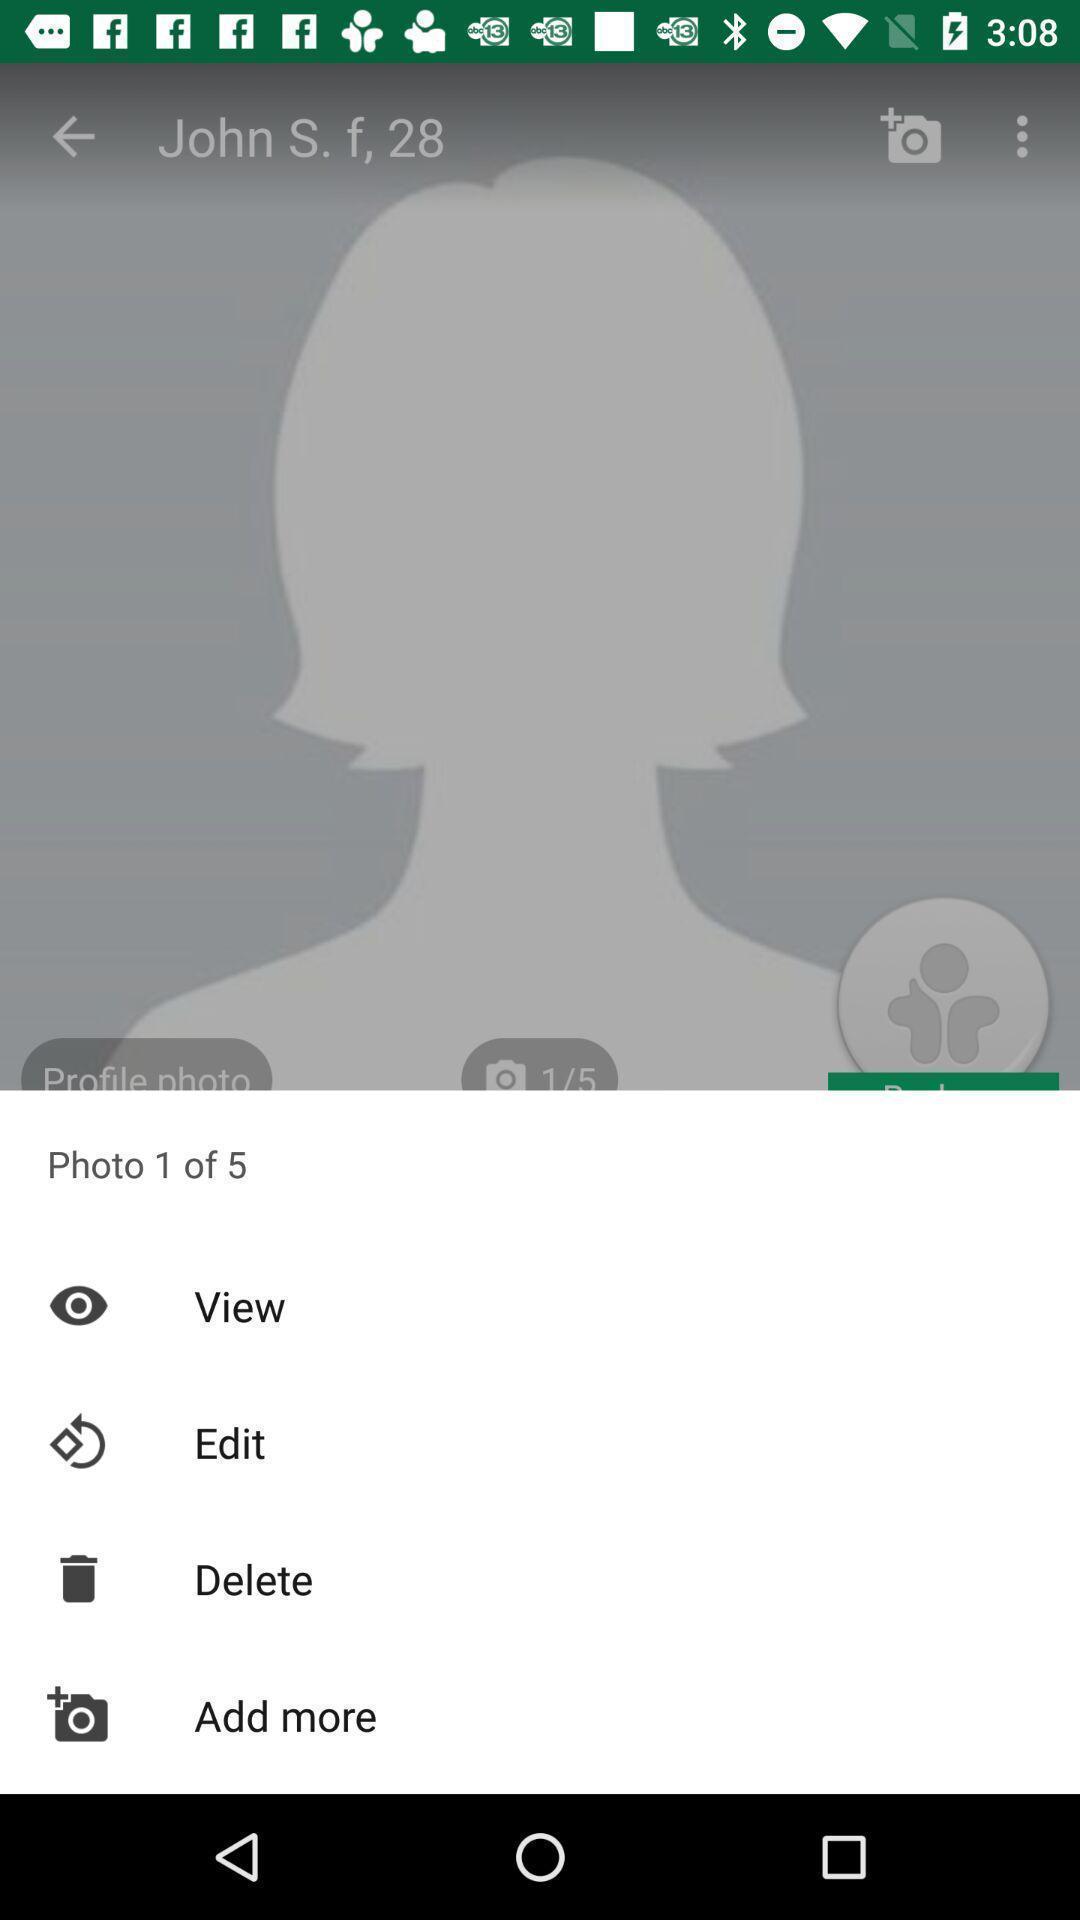Describe the content in this image. Pop-up showing various options for an image. 